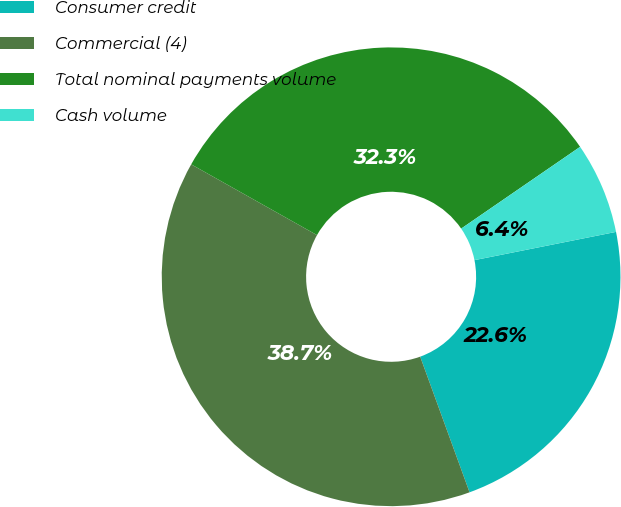Convert chart to OTSL. <chart><loc_0><loc_0><loc_500><loc_500><pie_chart><fcel>Consumer credit<fcel>Commercial (4)<fcel>Total nominal payments volume<fcel>Cash volume<nl><fcel>22.58%<fcel>38.71%<fcel>32.26%<fcel>6.45%<nl></chart> 